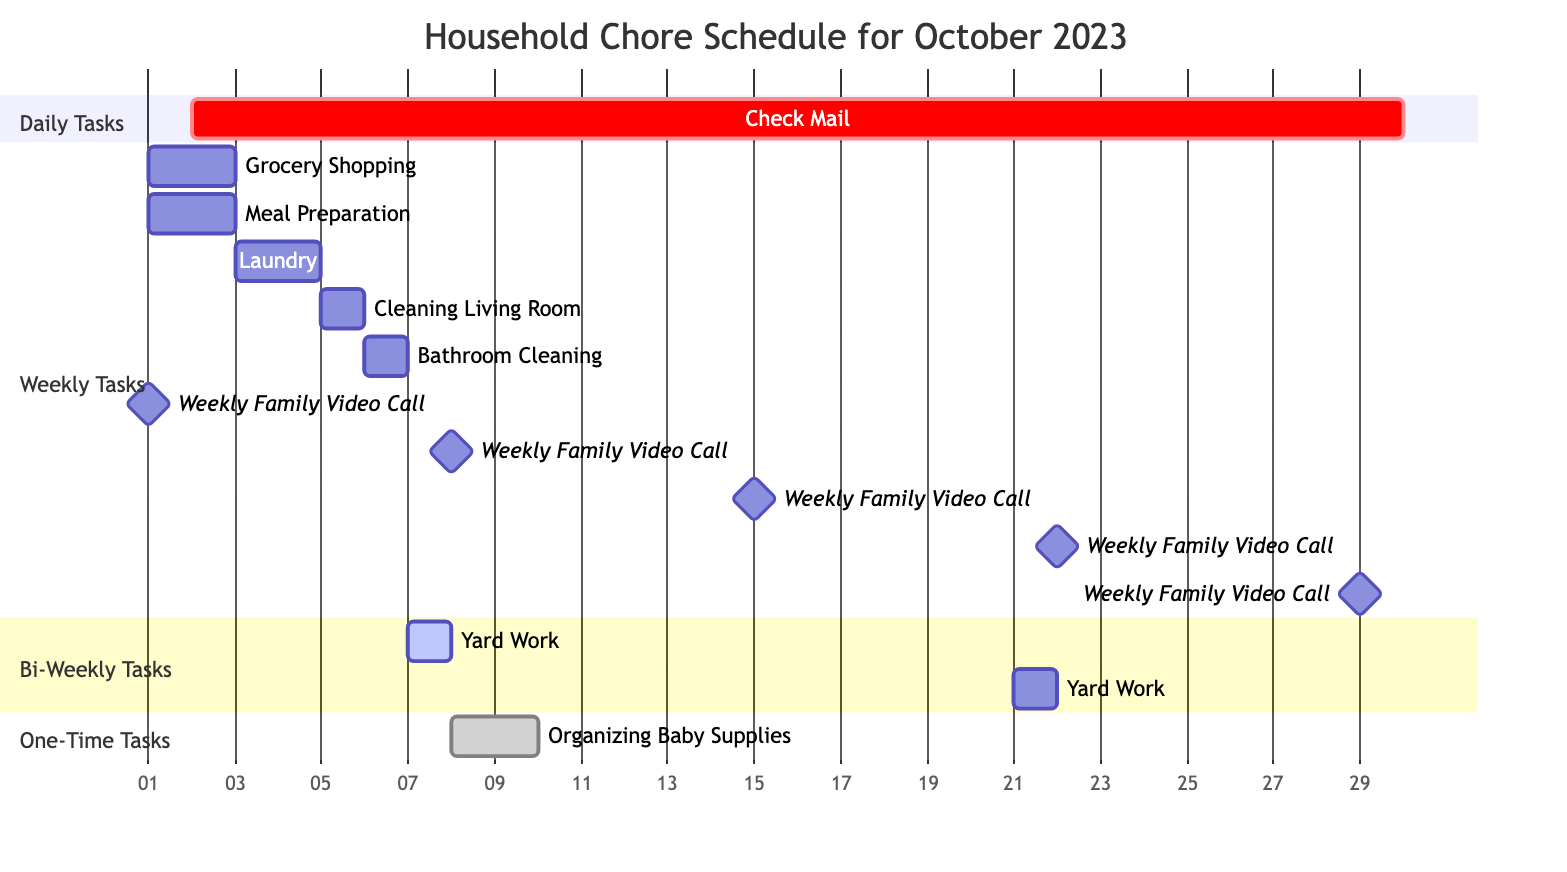What chores are scheduled for October 1st? According to the Gantt chart, Grocery Shopping and Meal Preparation are scheduled on October 1st. Both tasks have a start date of October 1st and are assigned to be done weekly.
Answer: Grocery Shopping, Meal Preparation How many daily tasks are in the schedule? The chart indicates there is one daily task, which is "Check Mail" scheduled for every day from October 2nd to October 29th.
Answer: One What is the duration of the Organizing Baby Supplies task? The task "Organizing Baby Supplies" is specified as lasting for 2 days, starting from October 8th to October 9th.
Answer: Two days On which week does the first Yard Work task occur? The first occurrence of Yard Work is scheduled on October 7th, which is within the first week of October 2023.
Answer: First week How many times will the Weekly Family Video Call take place in October? The chart illustrates that the Weekly Family Video Call occurs every week throughout October, which totals five times: on October 1, 8, 15, 22, and 29.
Answer: Five times What is the frequency of Laundry chores in the schedule? The Laundry chore is designated as a weekly task, meaning it occurs once every week. It starts on October 3rd and continues weekly thereafter.
Answer: Weekly Which task has the longest duration and what is that duration? The task "Check Mail" appears to span the longest duration from October 2nd to October 29th over a period of 28 days, indicating it is ongoing daily.
Answer: Twenty-eight days How often does Bathroom Cleaning occur during October? Bathroom Cleaning is marked as a weekly task, meaning it is performed once a week throughout the month of October.
Answer: Weekly 